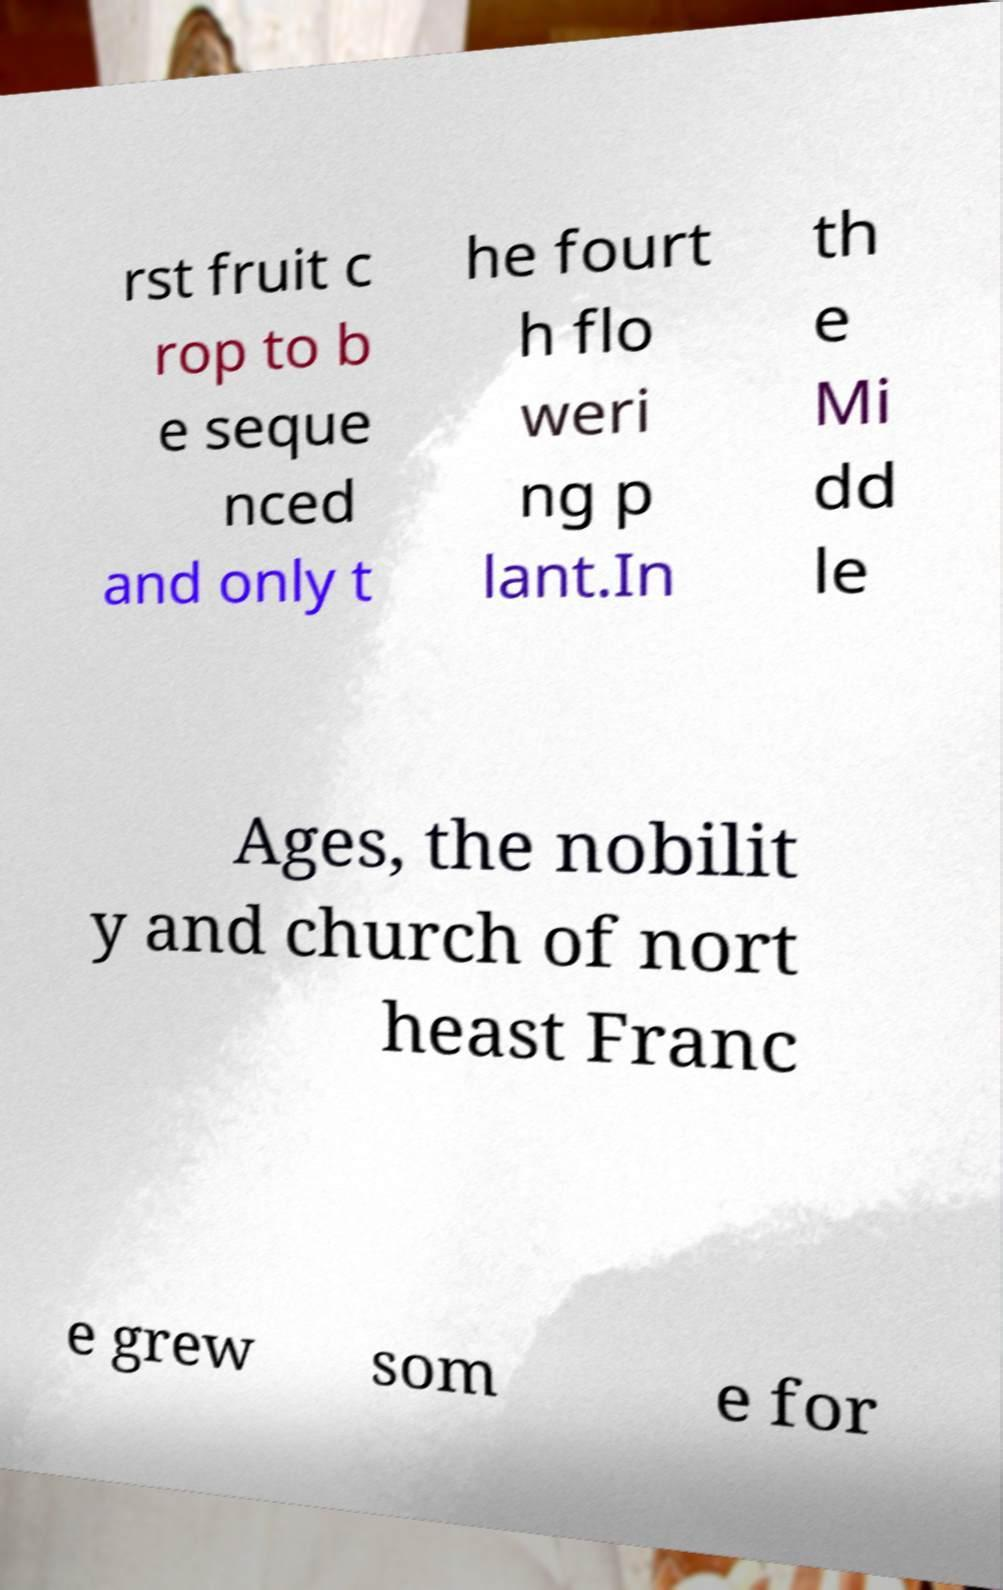Please identify and transcribe the text found in this image. rst fruit c rop to b e seque nced and only t he fourt h flo weri ng p lant.In th e Mi dd le Ages, the nobilit y and church of nort heast Franc e grew som e for 